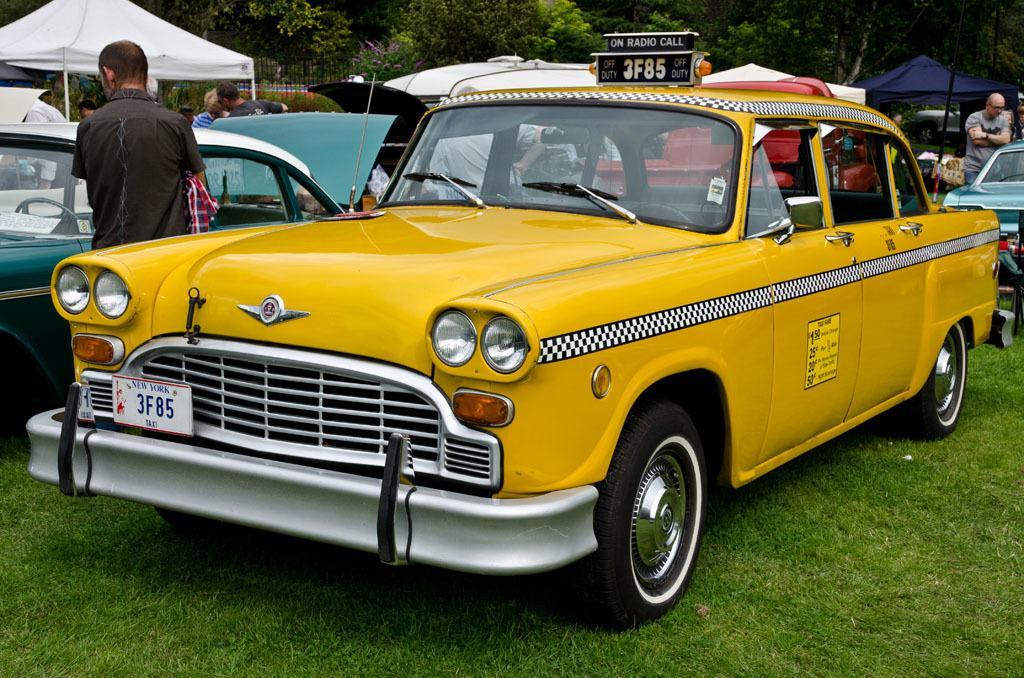Could you give a brief overview of what you see in this image? In the foreground blue and yellow color cars are visible and a group of people standing in front of the car. In the background top trees are visible and umbrella and tents are visible. At the bottom grass is visible and in the middle fence is visible. This image is taken on the ground during day time. 